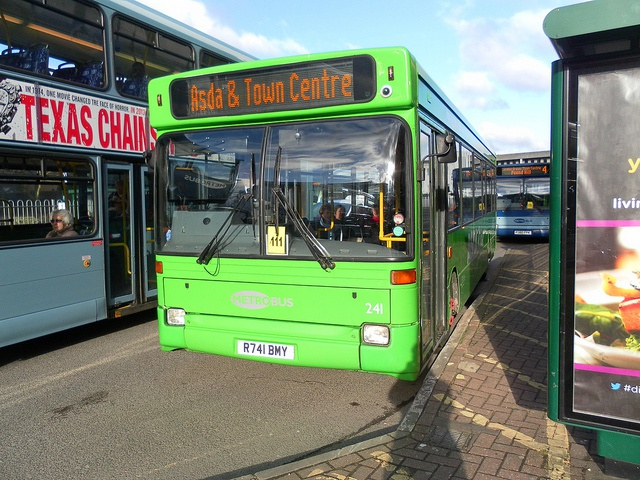Describe the objects in this image and their specific colors. I can see bus in black, gray, and lime tones, bus in black, gray, and navy tones, people in black, navy, and blue tones, people in black, gray, and darkblue tones, and people in black, gray, and maroon tones in this image. 